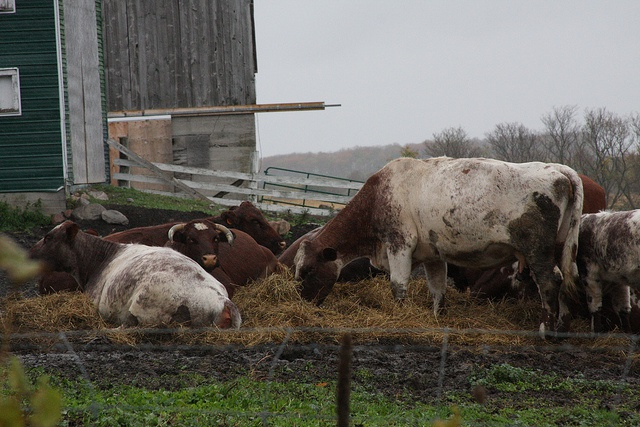Describe the objects in this image and their specific colors. I can see cow in darkgray, black, and gray tones, cow in darkgray, black, and gray tones, cow in darkgray, black, and gray tones, cow in darkgray, black, maroon, and gray tones, and cow in darkgray, black, maroon, gray, and lightgray tones in this image. 